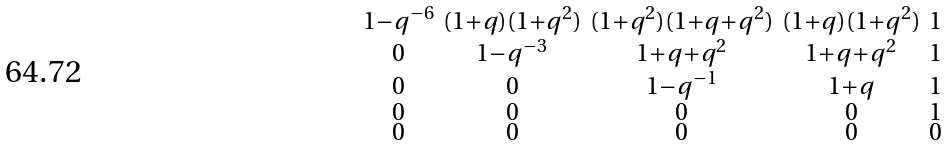Convert formula to latex. <formula><loc_0><loc_0><loc_500><loc_500>\begin{smallmatrix} 1 - q ^ { - 6 } & ( 1 + q ) ( 1 + q ^ { 2 } ) & ( 1 + q ^ { 2 } ) ( 1 + q + q ^ { 2 } ) & ( 1 + q ) ( 1 + q ^ { 2 } ) & 1 \\ 0 & 1 - q ^ { - 3 } & 1 + q + q ^ { 2 } & 1 + q + q ^ { 2 } & 1 \\ 0 & 0 & 1 - q ^ { - 1 } & 1 + q & 1 \\ 0 & 0 & 0 & 0 & 1 \\ 0 & 0 & 0 & 0 & 0 \\ \end{smallmatrix}</formula> 